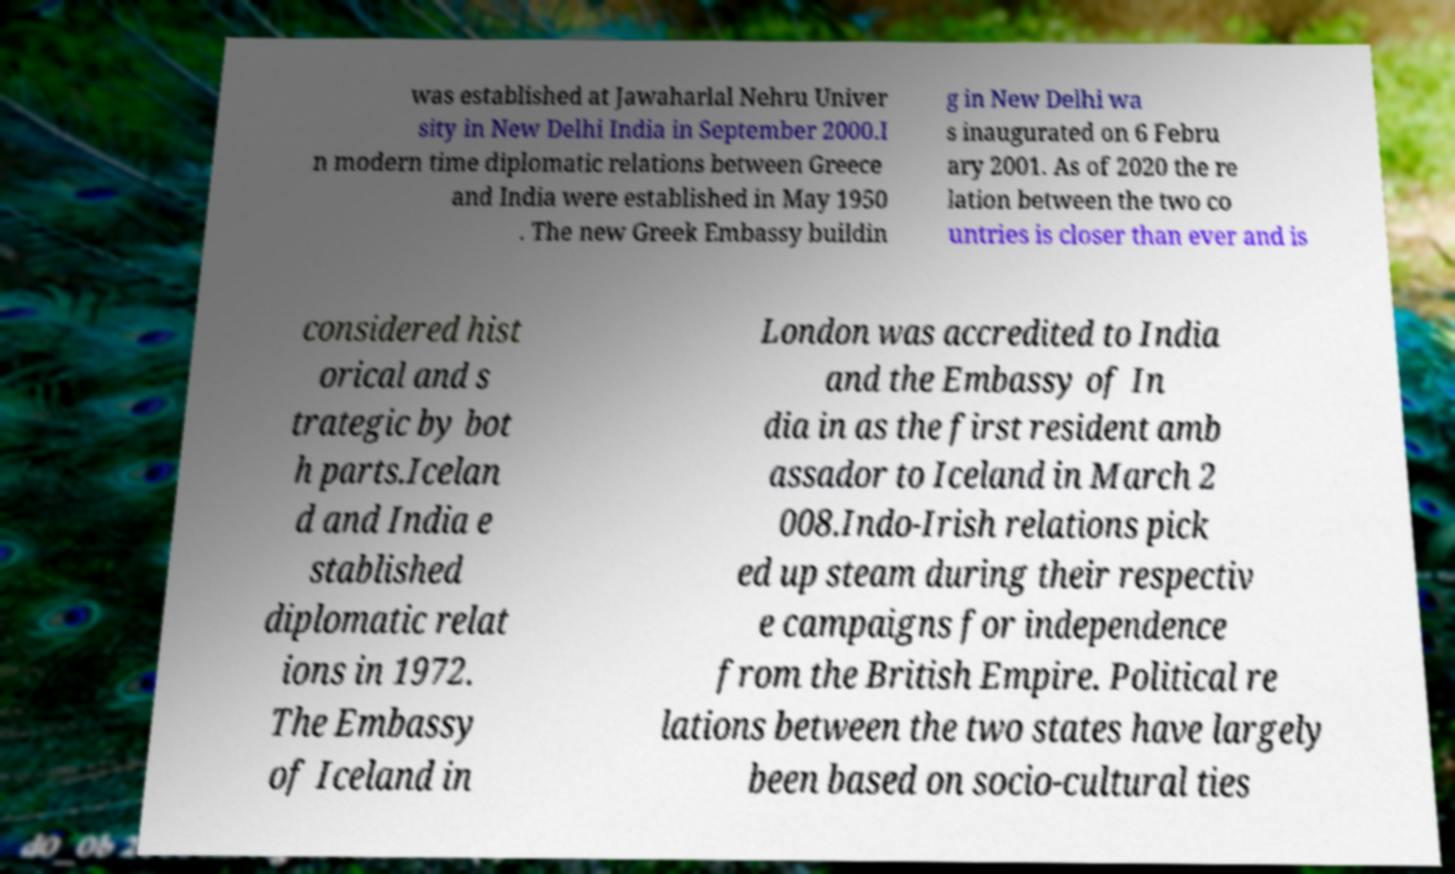Could you assist in decoding the text presented in this image and type it out clearly? was established at Jawaharlal Nehru Univer sity in New Delhi India in September 2000.I n modern time diplomatic relations between Greece and India were established in May 1950 . The new Greek Embassy buildin g in New Delhi wa s inaugurated on 6 Febru ary 2001. As of 2020 the re lation between the two co untries is closer than ever and is considered hist orical and s trategic by bot h parts.Icelan d and India e stablished diplomatic relat ions in 1972. The Embassy of Iceland in London was accredited to India and the Embassy of In dia in as the first resident amb assador to Iceland in March 2 008.Indo-Irish relations pick ed up steam during their respectiv e campaigns for independence from the British Empire. Political re lations between the two states have largely been based on socio-cultural ties 